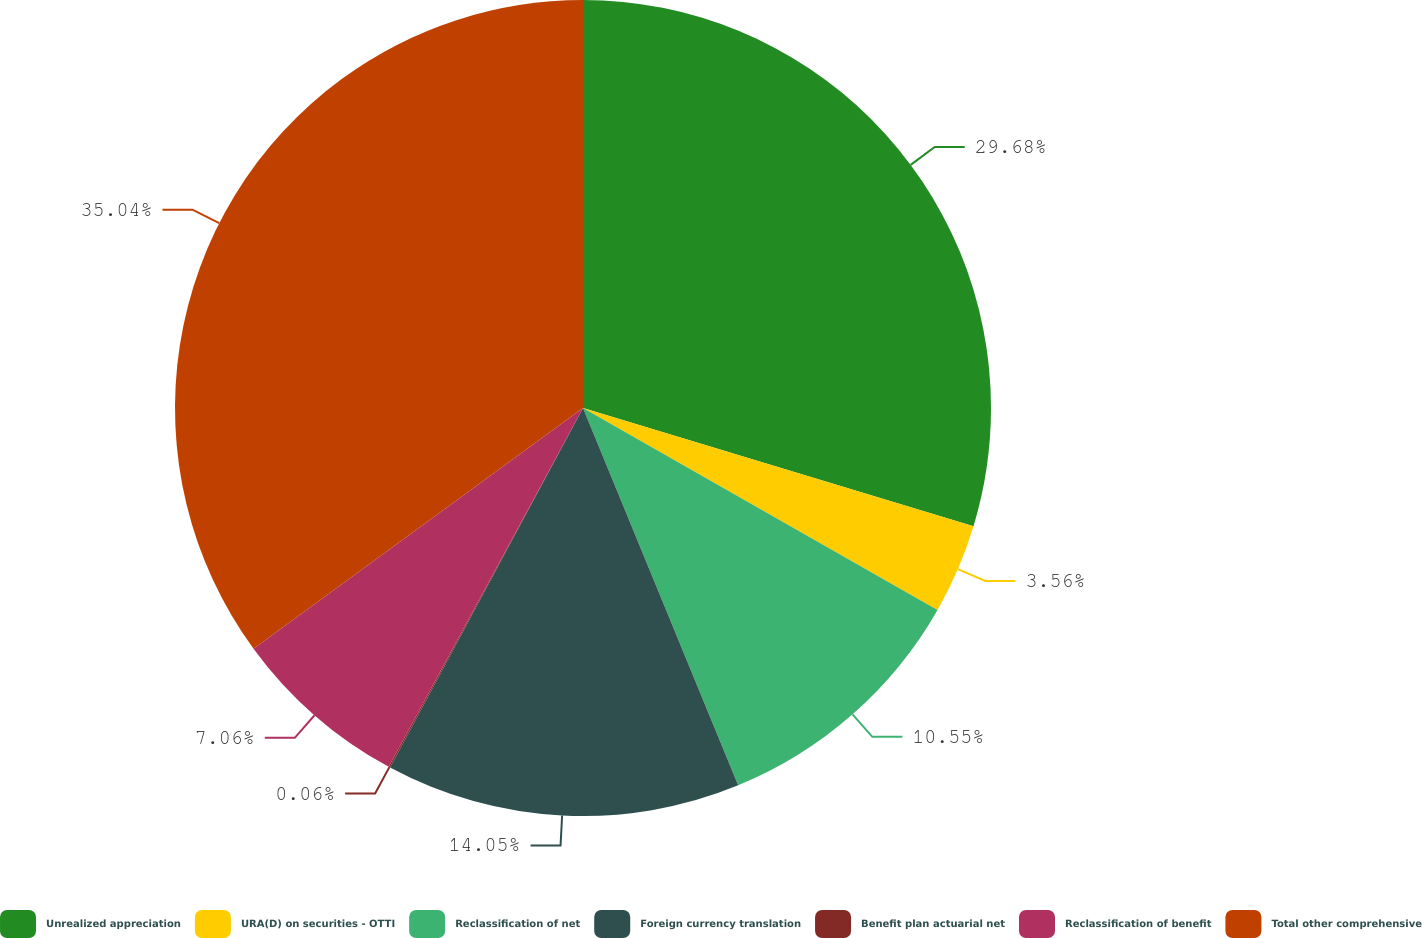Convert chart. <chart><loc_0><loc_0><loc_500><loc_500><pie_chart><fcel>Unrealized appreciation<fcel>URA(D) on securities - OTTI<fcel>Reclassification of net<fcel>Foreign currency translation<fcel>Benefit plan actuarial net<fcel>Reclassification of benefit<fcel>Total other comprehensive<nl><fcel>29.68%<fcel>3.56%<fcel>10.55%<fcel>14.05%<fcel>0.06%<fcel>7.06%<fcel>35.04%<nl></chart> 